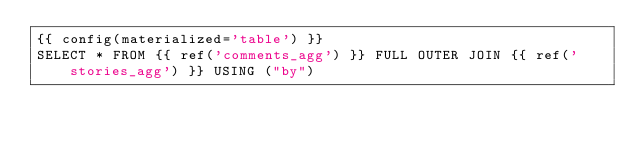<code> <loc_0><loc_0><loc_500><loc_500><_SQL_>{{ config(materialized='table') }}
SELECT * FROM {{ ref('comments_agg') }} FULL OUTER JOIN {{ ref('stories_agg') }} USING ("by")
</code> 